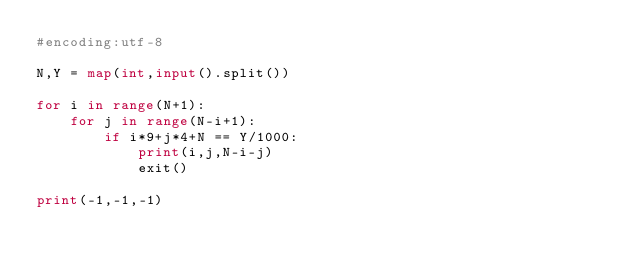Convert code to text. <code><loc_0><loc_0><loc_500><loc_500><_Python_>#encoding:utf-8

N,Y = map(int,input().split())

for i in range(N+1):
    for j in range(N-i+1):
        if i*9+j*4+N == Y/1000:
            print(i,j,N-i-j)
            exit()

print(-1,-1,-1)
</code> 